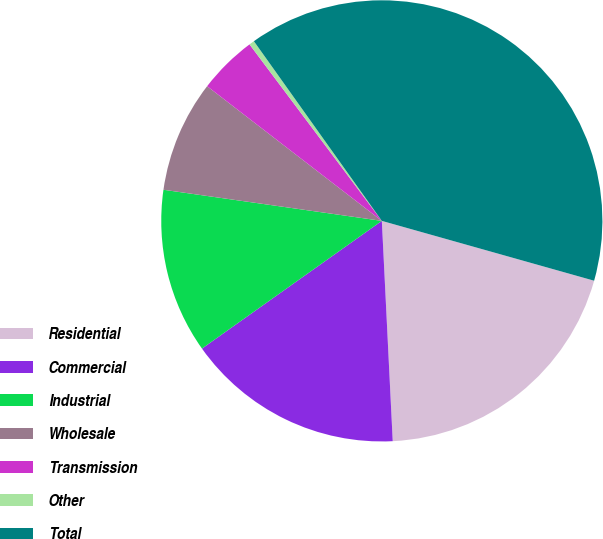<chart> <loc_0><loc_0><loc_500><loc_500><pie_chart><fcel>Residential<fcel>Commercial<fcel>Industrial<fcel>Wholesale<fcel>Transmission<fcel>Other<fcel>Total<nl><fcel>19.84%<fcel>15.96%<fcel>12.08%<fcel>8.2%<fcel>4.31%<fcel>0.39%<fcel>39.22%<nl></chart> 